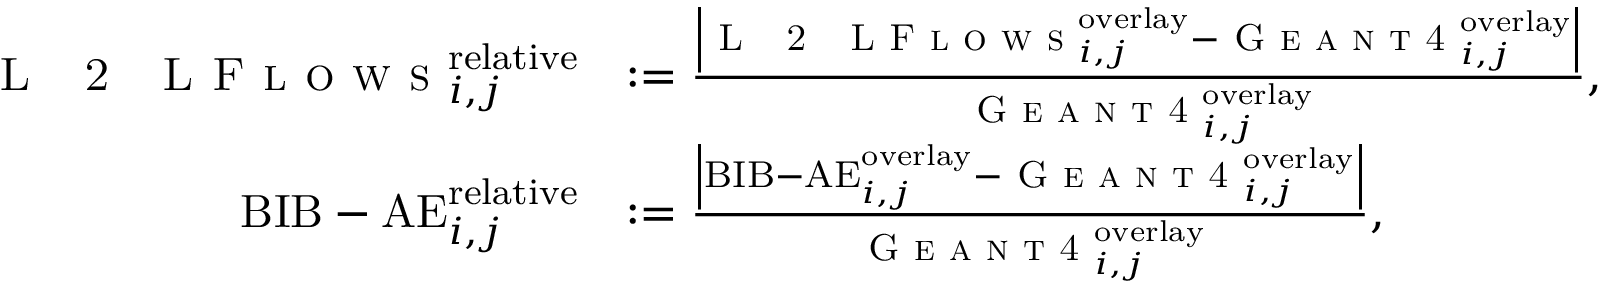Convert formula to latex. <formula><loc_0><loc_0><loc_500><loc_500>\begin{array} { r l } { L 2 L F l o w s _ { i , j } ^ { r e l a t i v e } } & { \colon = \frac { \left | L 2 L F l o w s _ { i , j } ^ { o v e r l a y } - G e a n t 4 _ { i , j } ^ { o v e r l a y } \right | } { G e a n t 4 _ { i , j } ^ { o v e r l a y } } , } \\ { B I B - A E _ { i , j } ^ { r e l a t i v e } } & { \colon = \frac { \left | B I B - A E _ { i , j } ^ { o v e r l a y } - G e a n t 4 _ { i , j } ^ { o v e r l a y } \right | } { G e a n t 4 _ { i , j } ^ { o v e r l a y } } , } \end{array}</formula> 